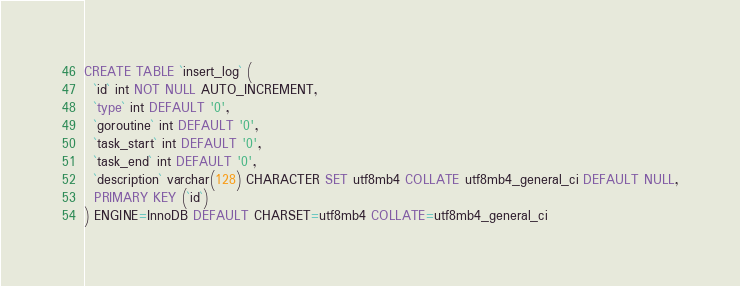<code> <loc_0><loc_0><loc_500><loc_500><_SQL_>CREATE TABLE `insert_log` (
  `id` int NOT NULL AUTO_INCREMENT,
  `type` int DEFAULT '0',
  `goroutine` int DEFAULT '0',
  `task_start` int DEFAULT '0',
  `task_end` int DEFAULT '0',
  `description` varchar(128) CHARACTER SET utf8mb4 COLLATE utf8mb4_general_ci DEFAULT NULL,
  PRIMARY KEY (`id`)
) ENGINE=InnoDB DEFAULT CHARSET=utf8mb4 COLLATE=utf8mb4_general_ci</code> 